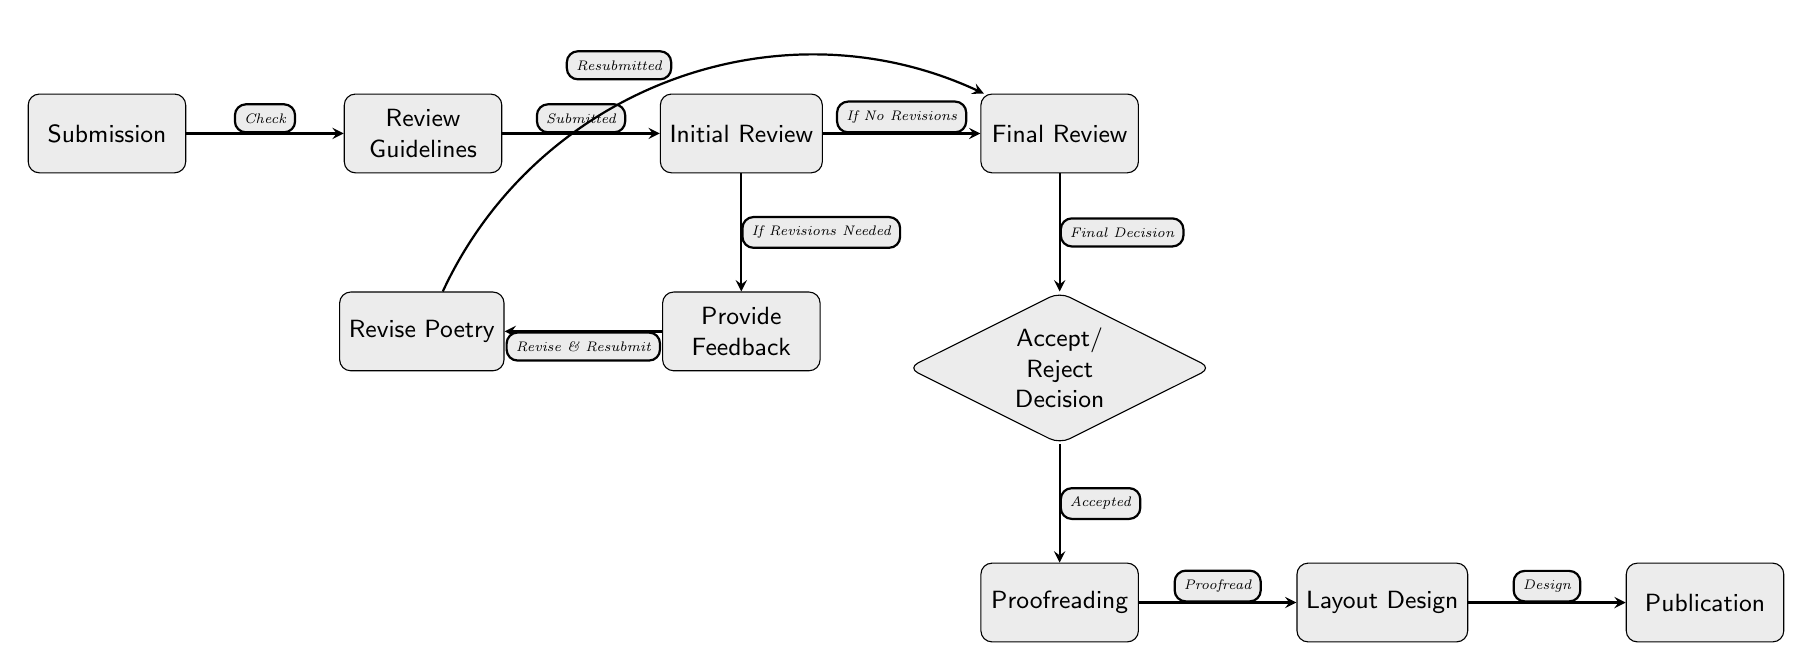What is the first step in the publishing process? The first step in the process is the "Submission" node, indicating that authors begin by submitting their poetry for consideration.
Answer: Submission How many main nodes are there in the diagram? The diagram contains a total of 8 main nodes that represent different stages of the poetry publishing process.
Answer: 8 What happens after the "Initial Review"? After the "Initial Review," the process moves to either the "Feedback" node if revisions are needed or directly to the "Final Review" node if no revisions are necessary.
Answer: Feedback or Final Review What is the final step in the publishing process? The final step in the process is the "Publication" node, which signifies the completion of the entire publishing journey.
Answer: Publication If the poetry is accepted, what is the next phase? If the poetry is accepted, it proceeds to the "Proofreading" phase, where final corrections and adjustments are made before layout design.
Answer: Proofreading What is the decision point in the process? The decision point in the process is at the "Accept/Reject Decision" node, where the work is evaluated to determine whether it will be accepted or rejected for publication.
Answer: Accept/Reject Decision What does the arrow from "Feedback" to "Revise Poetry" indicate? The arrow from "Feedback" to "Revise Poetry" indicates that poets are required to revise their work based on the feedback they receive during the review process.
Answer: Revise Poetry What indicates that the poetry has been submitted? The transition from the "Review Guidelines" node to the "Initial Review" node indicates that the submission has been made and that the work is now under review.
Answer: Submitted 